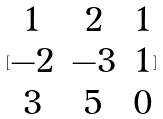Convert formula to latex. <formula><loc_0><loc_0><loc_500><loc_500>[ \begin{matrix} 1 & 2 & 1 \\ - 2 & - 3 & 1 \\ 3 & 5 & 0 \end{matrix} ]</formula> 